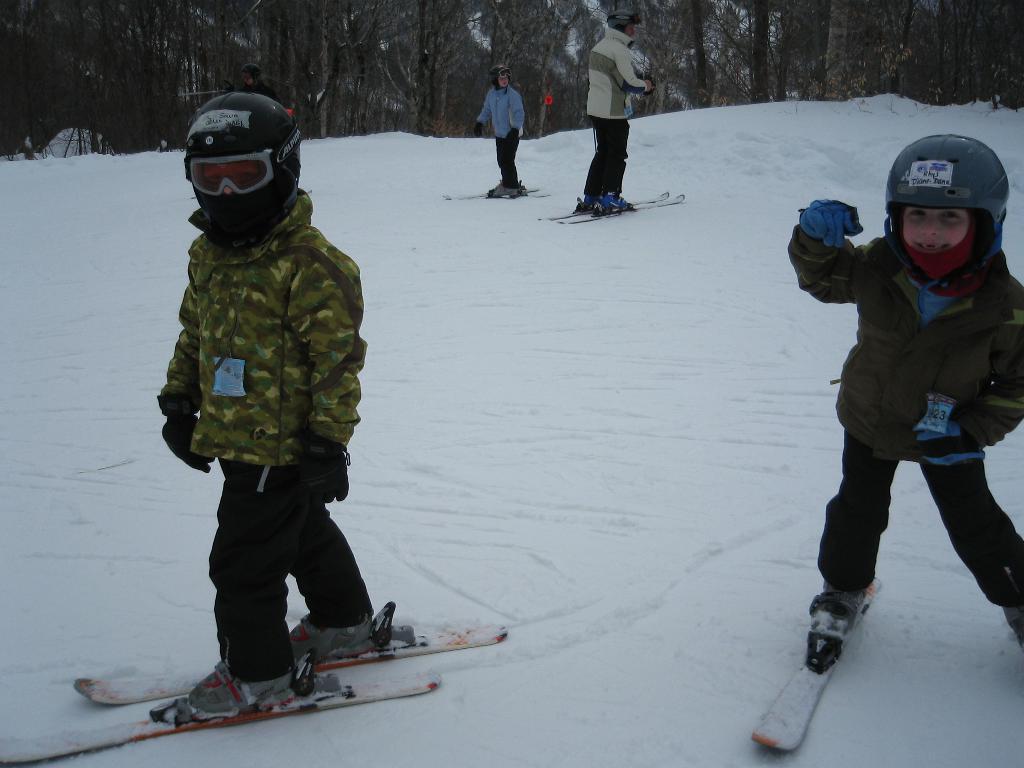In one or two sentences, can you explain what this image depicts? In this picture we can see there are five people skating with the ski boards on the snow and behind the people there are trees. 